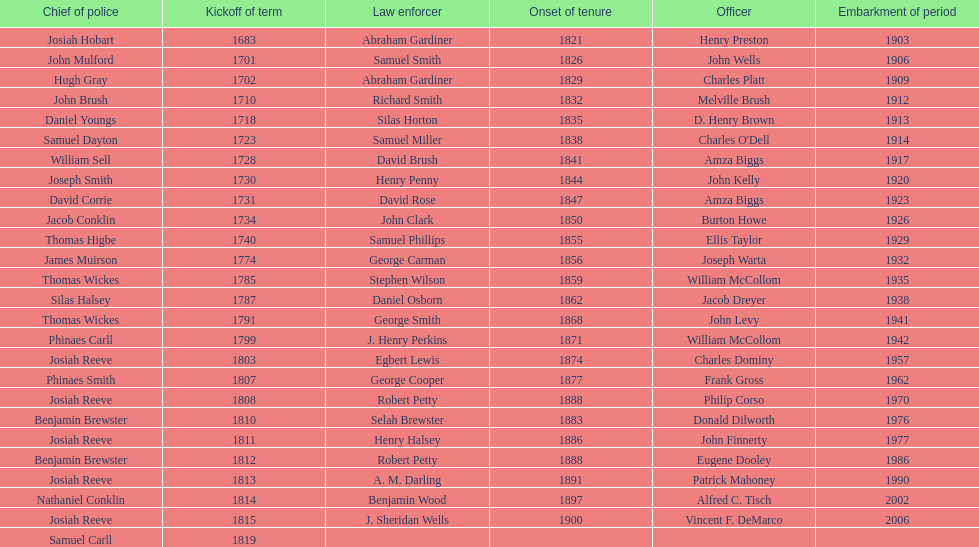What is the total number of sheriffs that were in office in suffolk county between 1903 and 1957? 17. 